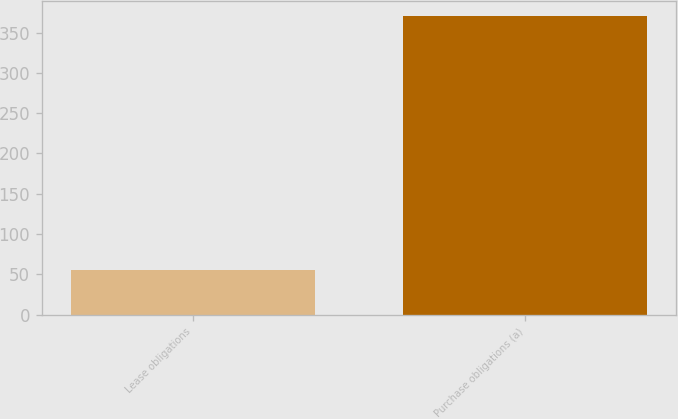Convert chart to OTSL. <chart><loc_0><loc_0><loc_500><loc_500><bar_chart><fcel>Lease obligations<fcel>Purchase obligations (a)<nl><fcel>55<fcel>371<nl></chart> 